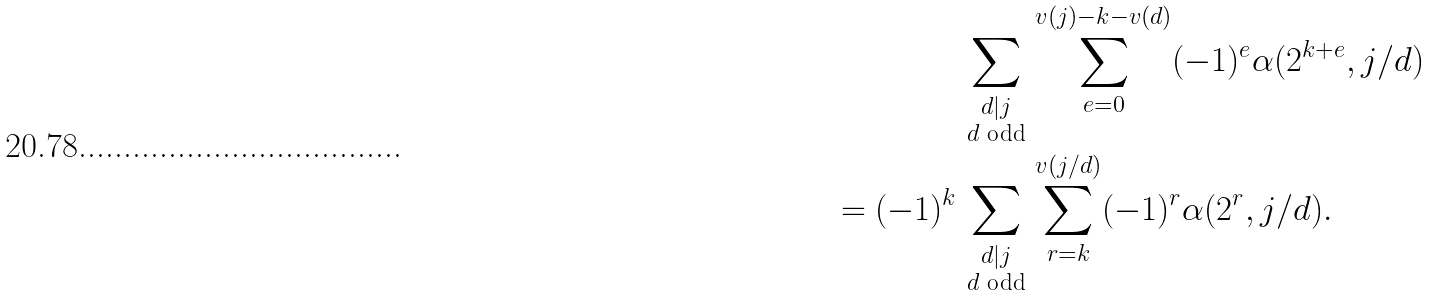<formula> <loc_0><loc_0><loc_500><loc_500>\sum _ { \begin{smallmatrix} d | j \\ \text {$d$ odd} \end{smallmatrix} } & \sum _ { e = 0 } ^ { v ( j ) - k - v ( d ) } ( - 1 ) ^ { e } \alpha ( 2 ^ { k + e } , j / d ) \\ = ( - 1 ) ^ { k } \sum _ { \begin{smallmatrix} d | j \\ \text {$d$ odd} \end{smallmatrix} } & \sum _ { r = k } ^ { v ( j / d ) } ( - 1 ) ^ { r } \alpha ( 2 ^ { r } , j / d ) .</formula> 